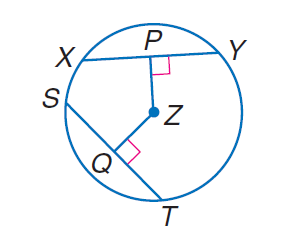Answer the mathemtical geometry problem and directly provide the correct option letter.
Question: In \odot Z, P Z = Z Q, X Y = 4 a - 5, and S T = - 5 a + 13. Find S Q.
Choices: A: 1.5 B: 2 C: 3 D: 4 A 